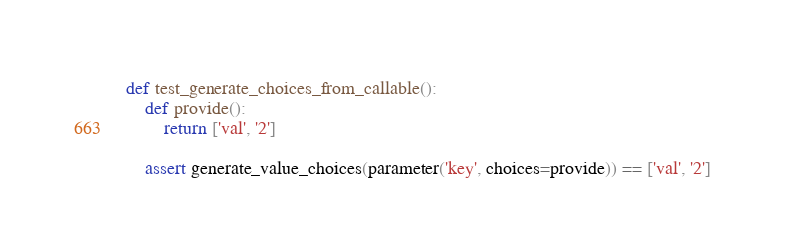<code> <loc_0><loc_0><loc_500><loc_500><_Python_>
def test_generate_choices_from_callable():
    def provide():
        return ['val', '2']

    assert generate_value_choices(parameter('key', choices=provide)) == ['val', '2']
</code> 